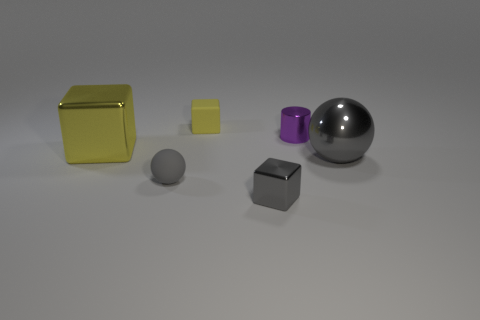Is the metal sphere the same color as the matte sphere?
Give a very brief answer. Yes. What number of small objects are either rubber blocks or yellow metal objects?
Give a very brief answer. 1. There is a tiny block that is the same color as the large metal block; what is its material?
Offer a very short reply. Rubber. Are there any tiny purple things that have the same material as the gray block?
Make the answer very short. Yes. There is a gray sphere that is to the left of the metal sphere; is its size the same as the big gray thing?
Provide a succinct answer. No. There is a tiny gray thing in front of the tiny matte object that is in front of the big gray object; is there a small object that is left of it?
Ensure brevity in your answer.  Yes. How many metal objects are big gray objects or yellow objects?
Your answer should be compact. 2. How many other things are there of the same shape as the tiny gray shiny object?
Ensure brevity in your answer.  2. Is the number of gray blocks greater than the number of gray balls?
Provide a short and direct response. No. What is the size of the gray thing that is on the left side of the tiny block that is in front of the gray ball that is left of the tiny yellow matte thing?
Provide a short and direct response. Small. 